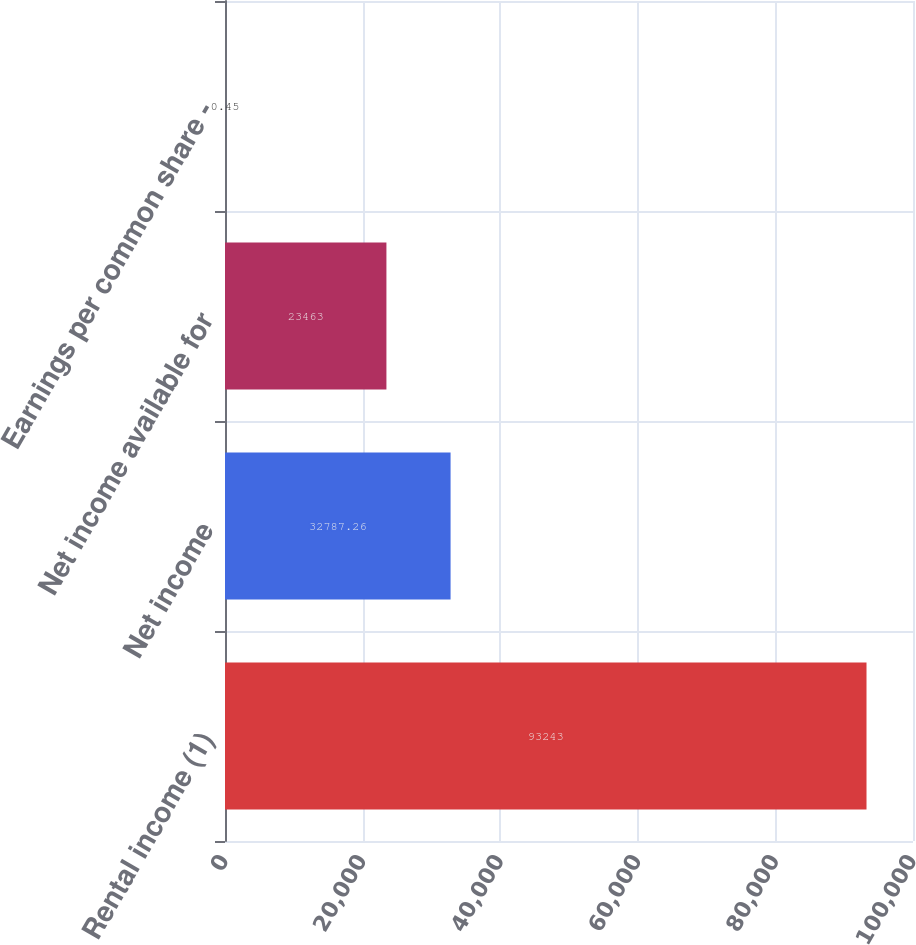Convert chart to OTSL. <chart><loc_0><loc_0><loc_500><loc_500><bar_chart><fcel>Rental income (1)<fcel>Net income<fcel>Net income available for<fcel>Earnings per common share -<nl><fcel>93243<fcel>32787.3<fcel>23463<fcel>0.45<nl></chart> 